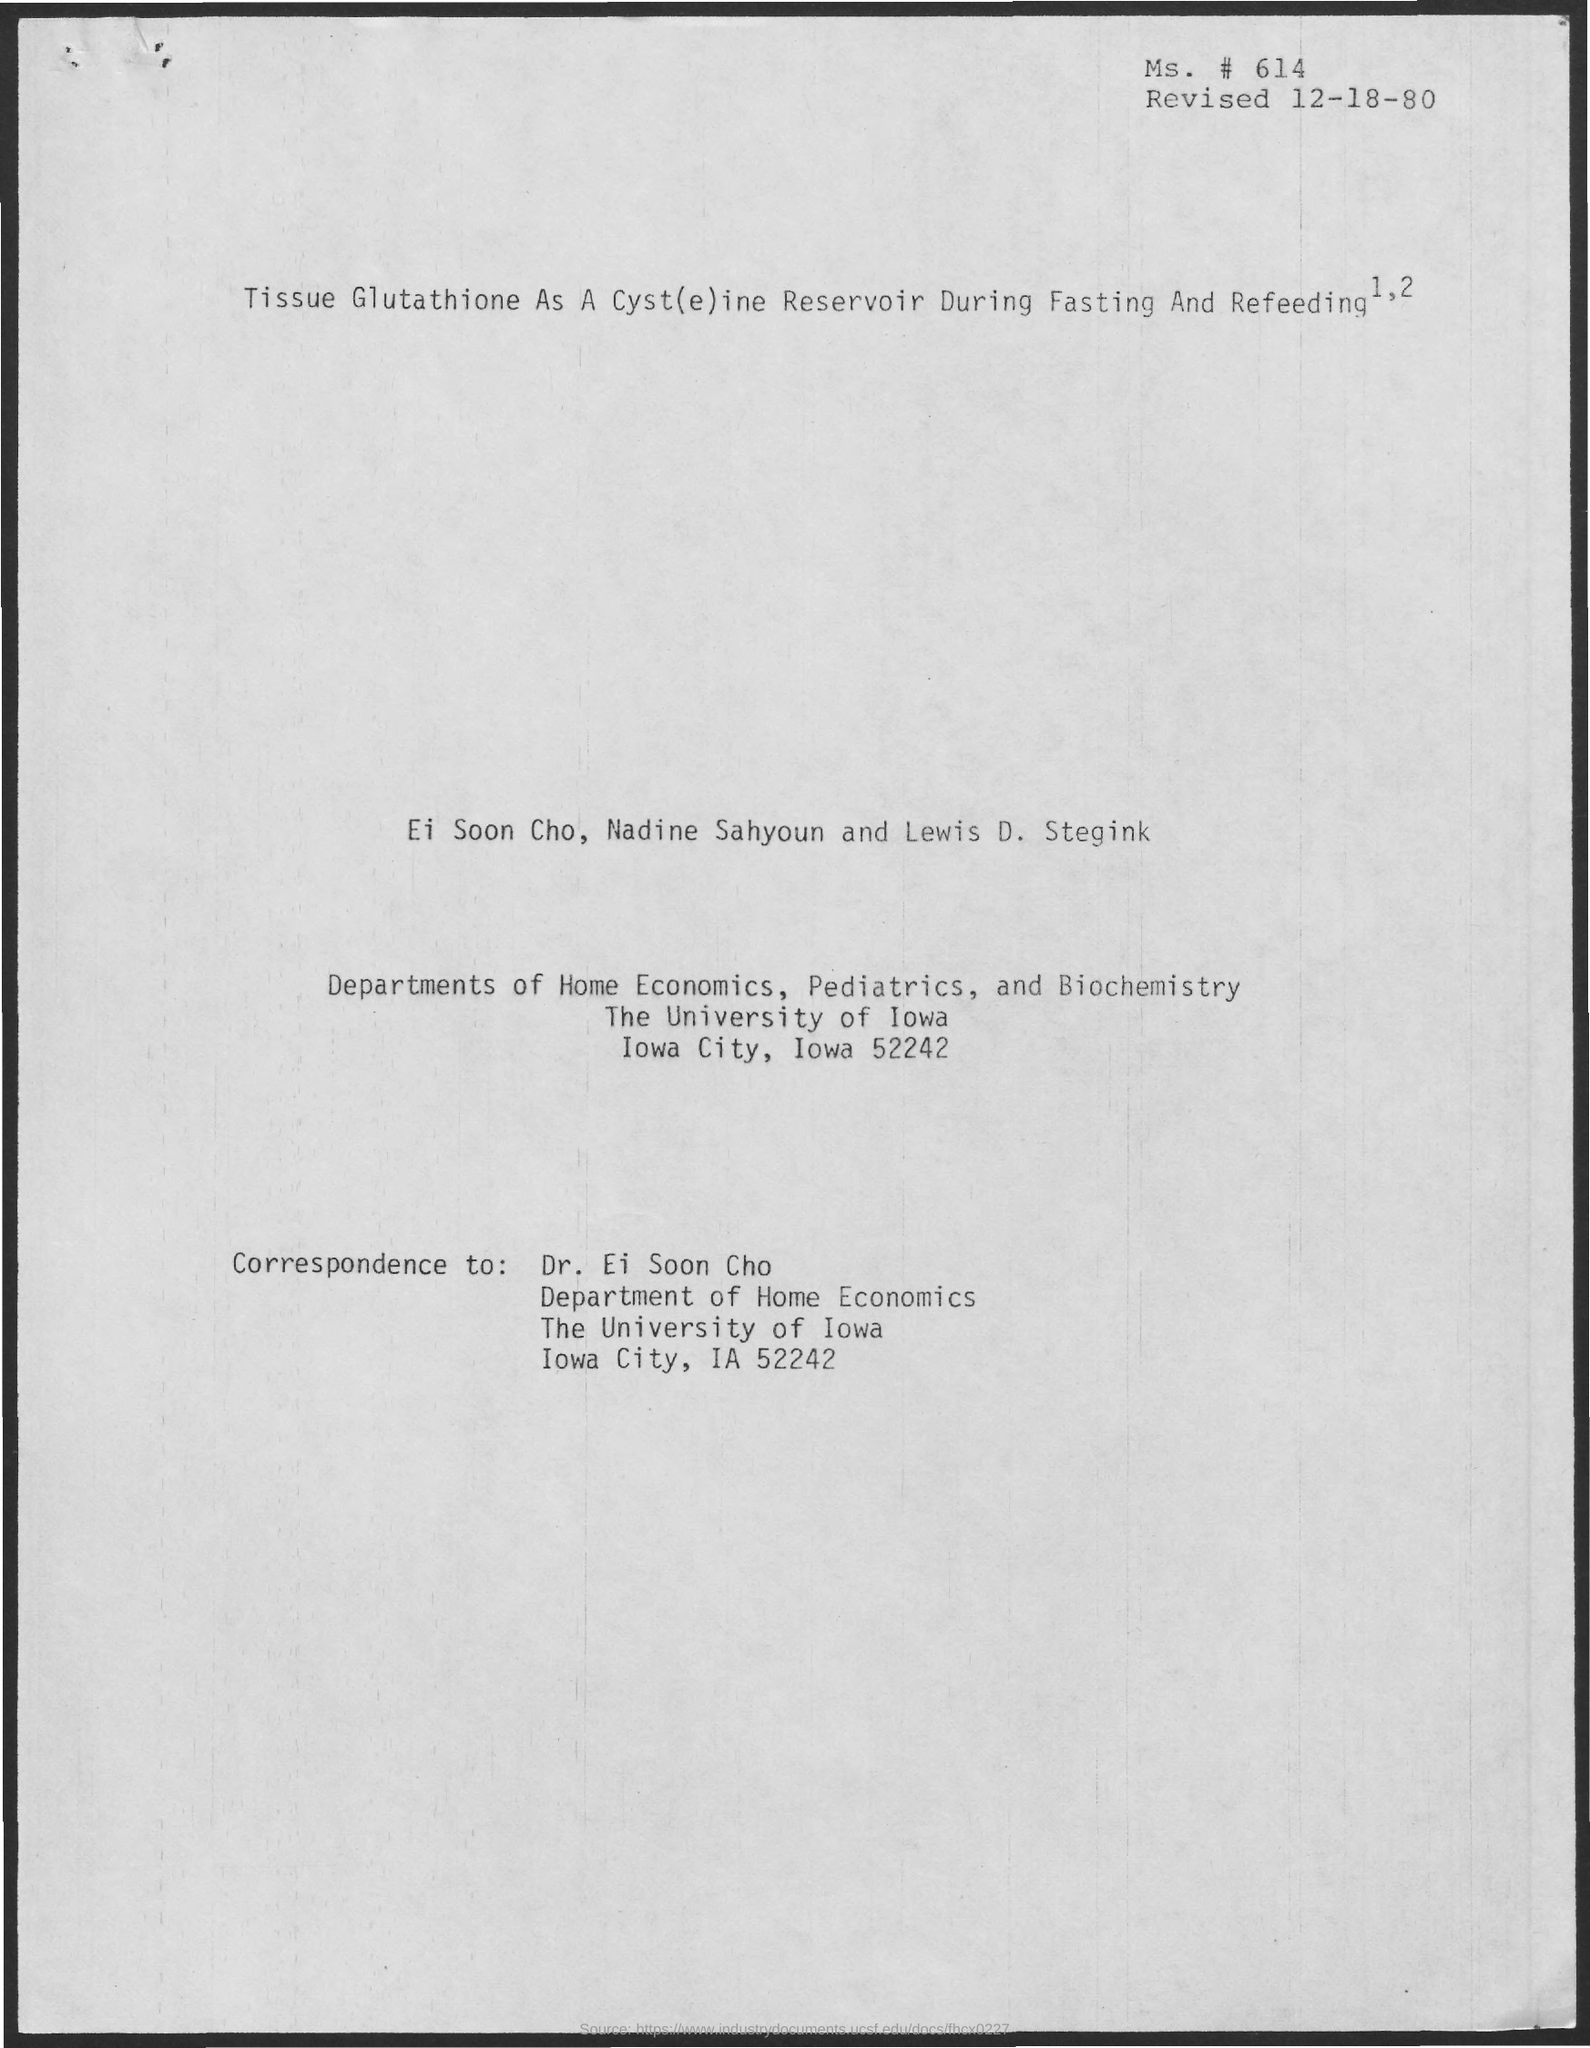Who is the person to which the correspondences to be addressesd to?
Provide a short and direct response. Dr. Ei Soon Cho. When was the document revised?
Your response must be concise. 12-18-80. 